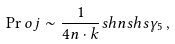Convert formula to latex. <formula><loc_0><loc_0><loc_500><loc_500>\Pr o j \sim \frac { 1 } { 4 n \cdot k } \sl s h { n } \sl s h { s } \gamma _ { 5 } \, ,</formula> 